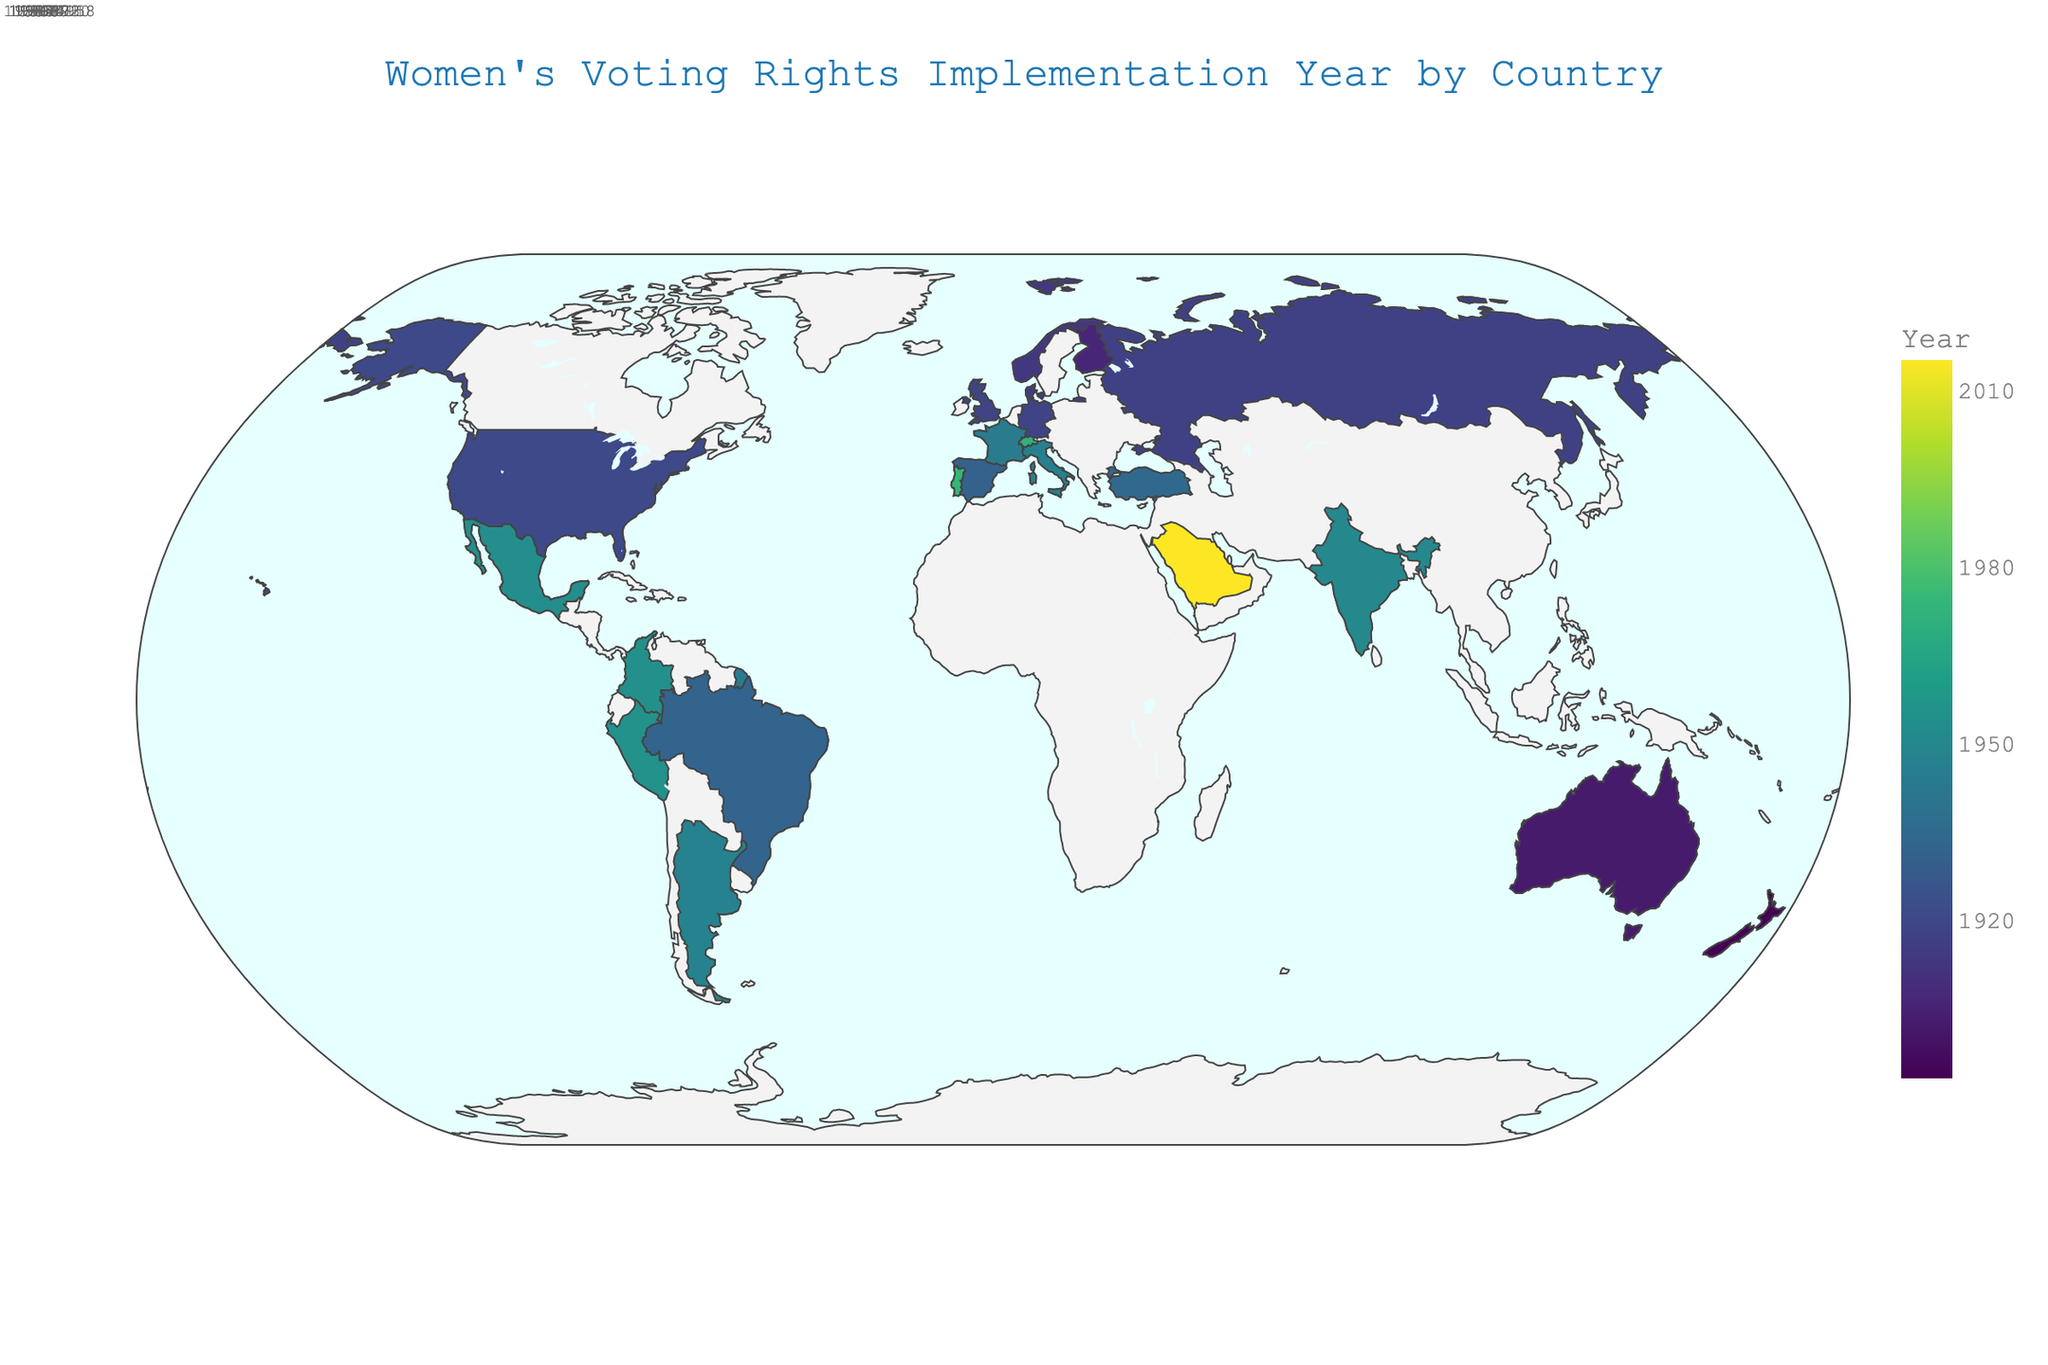What's the title of the figure? The title is usually displayed prominently at the top of the figure. In this case, it describes the overall theme of the plot.
Answer: Women's Voting Rights Implementation Year by Country Which country was the first to implement voting rights for women? By observing the colors that represent the years on the plot, the earliest year can be determined. New Zealand is the country with the year 1893.
Answer: New Zealand How many countries implemented women's voting rights before 1920? Count the number of countries on the figure that have implementation years prior to 1920. These countries are New Zealand (1893), Australia (1902), Finland (1906), Norway (1913), Denmark (1915), Russia (1917), United Kingdom (1918), and Germany (1918).
Answer: 8 Which region has the most countries implementing voting rights for women after 1950? Look at the regions associated with the countries that implemented voting rights for women after 1950, namely India, Mexico, Colombia, Peru, Switzerland, Portugal, and Saudi Arabia. Europe has Switzerland and Portugal. North America has Mexico. Asia has India and Saudi Arabia. South America has Colombia and Peru. Hence, Europe has the most.
Answer: Europe What is the latest year shown on the plot for the implementation of women's voting rights? By looking at the year representation on the plot, the latest year that stands out is for Saudi Arabia, which is 2015.
Answer: 2015 Which country in South America was the first to implement voting rights for women? Locate South American countries on the figure and identify the earliest year among them. Brazil is the country with the year 1932, which is the earliest.
Answer: Brazil Compare the implementation years of women's voting rights in Spain and France. Which country granted it earlier? Observe the respective years shown for Spain and France. Spain's year is 1931, while France's year is 1944. Spain granted it earlier.
Answer: Spain What is the time difference between women's voting rights implementations in the United States and Saudi Arabia? Find the years for the United States (1920) and Saudi Arabia (2015) and calculate the difference: 2015 - 1920.
Answer: 95 years Which continent has the widest range of years for implementing women's voting rights? Examine the years of countries within each continent. Europe has the range from Finland (1906) to Portugal (1974), which gives a range of 1974 - 1906 = 68 years. Other continents have smaller ranges.
Answer: Europe How many countries implemented women's voting rights in the 1950s? Identify the countries with years in the 1950s: India (1950), Mexico (1953), Colombia (1954), Peru (1955). Count these countries.
Answer: 4 